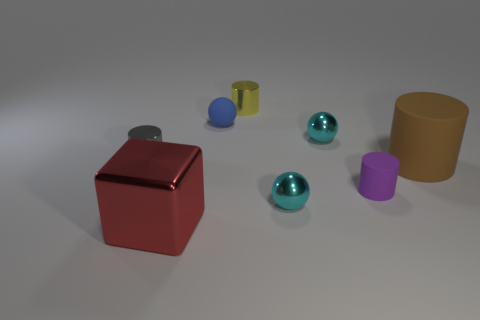Subtract all gray cylinders. How many cylinders are left? 3 Subtract all yellow cylinders. How many cylinders are left? 3 Subtract 1 balls. How many balls are left? 2 Subtract all blue cylinders. Subtract all brown blocks. How many cylinders are left? 4 Add 1 rubber spheres. How many objects exist? 9 Subtract all blocks. How many objects are left? 7 Subtract all big cyan rubber cylinders. Subtract all tiny gray metal objects. How many objects are left? 7 Add 6 tiny blue balls. How many tiny blue balls are left? 7 Add 3 tiny green metallic objects. How many tiny green metallic objects exist? 3 Subtract 0 blue cylinders. How many objects are left? 8 